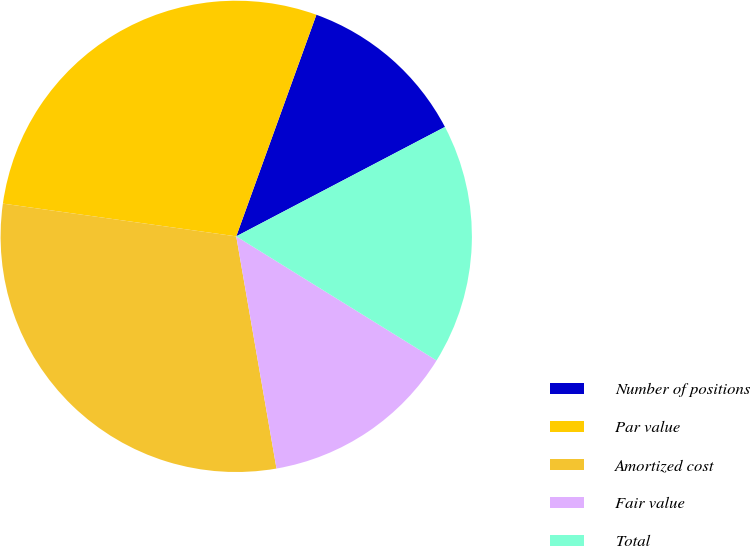Convert chart to OTSL. <chart><loc_0><loc_0><loc_500><loc_500><pie_chart><fcel>Number of positions<fcel>Par value<fcel>Amortized cost<fcel>Fair value<fcel>Total<nl><fcel>11.79%<fcel>28.3%<fcel>29.95%<fcel>13.44%<fcel>16.51%<nl></chart> 